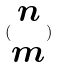<formula> <loc_0><loc_0><loc_500><loc_500>( \begin{matrix} n \\ m \end{matrix} )</formula> 